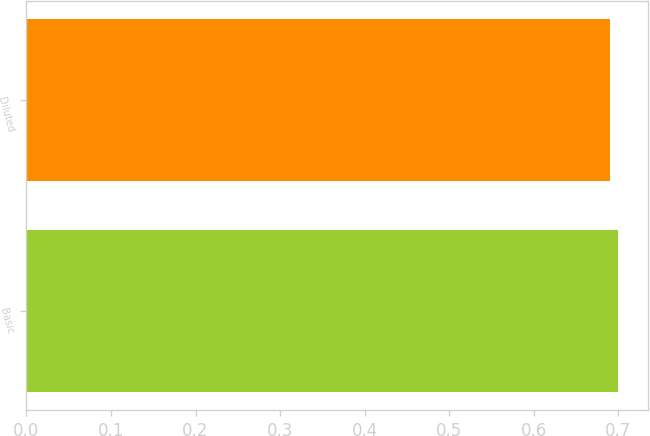<chart> <loc_0><loc_0><loc_500><loc_500><bar_chart><fcel>Basic<fcel>Diluted<nl><fcel>0.7<fcel>0.69<nl></chart> 